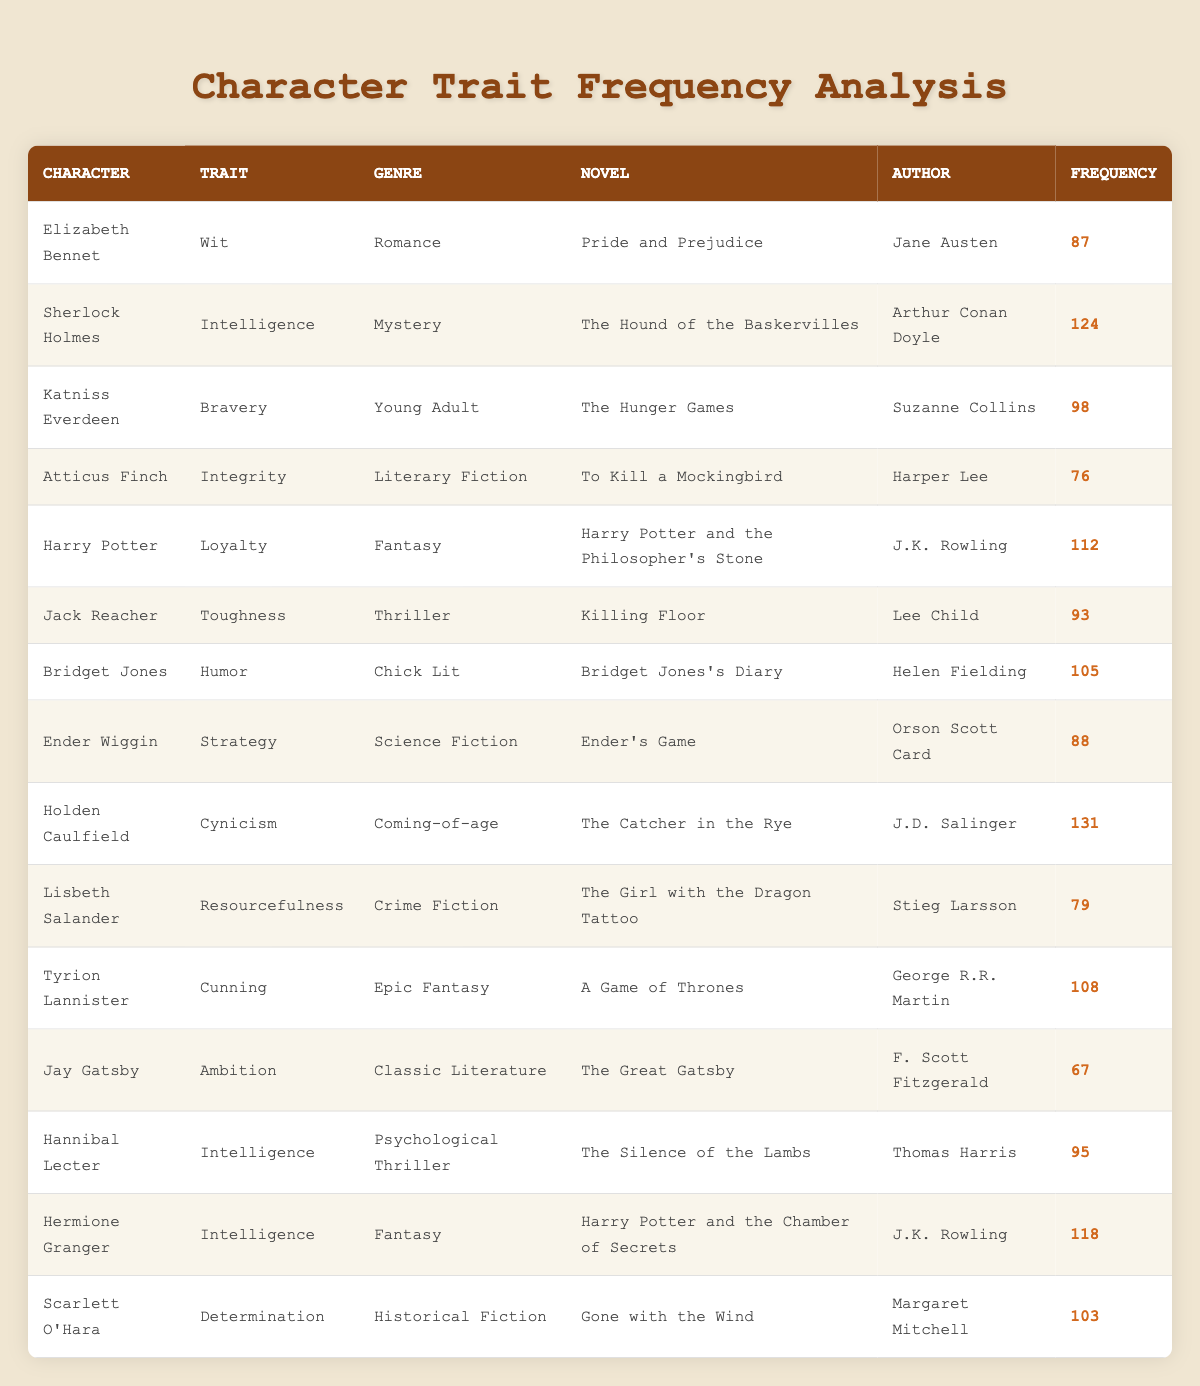What character from the Romance genre has the highest trait frequency? In the table, I look at the characters in the Romance genre. I see Elizabeth Bennet with a frequency of 87. There are no other Romance characters, so she has the highest frequency in that genre.
Answer: Elizabeth Bennet Which character has the highest frequency of the "Intelligence" trait? I check the table for characters with the "Intelligence" trait. There are three: Sherlock Holmes with 124, Hannibal Lecter with 95, and Hermione Granger with 118. The highest frequency is 124.
Answer: Sherlock Holmes How many characters have a frequency greater than 100? I review the table and count the characters: Sherlock Holmes (124), Harry Potter (112), Hermione Granger (118), Jack Reacher (105), Bridget Jones (105), Tyrion Lannister (108), and Scarlett O'Hara (103). That's seven characters with a frequency greater than 100.
Answer: 7 Is there a character from the Epic Fantasy genre with a frequency less than 100? Looking at the table, Tyrion Lannister is the only character from the Epic Fantasy genre with a frequency of 108, which is not less than 100. So, there isn't a character from this genre with a frequency less than 100.
Answer: No What is the average frequency of characters in the Fantasy genre? The table lists two characters in the Fantasy genre: Harry Potter (112) and Hermione Granger (118). To find the average, I add their frequencies together (112 + 118 = 230) and divide by 2. The average frequency is 115.
Answer: 115 